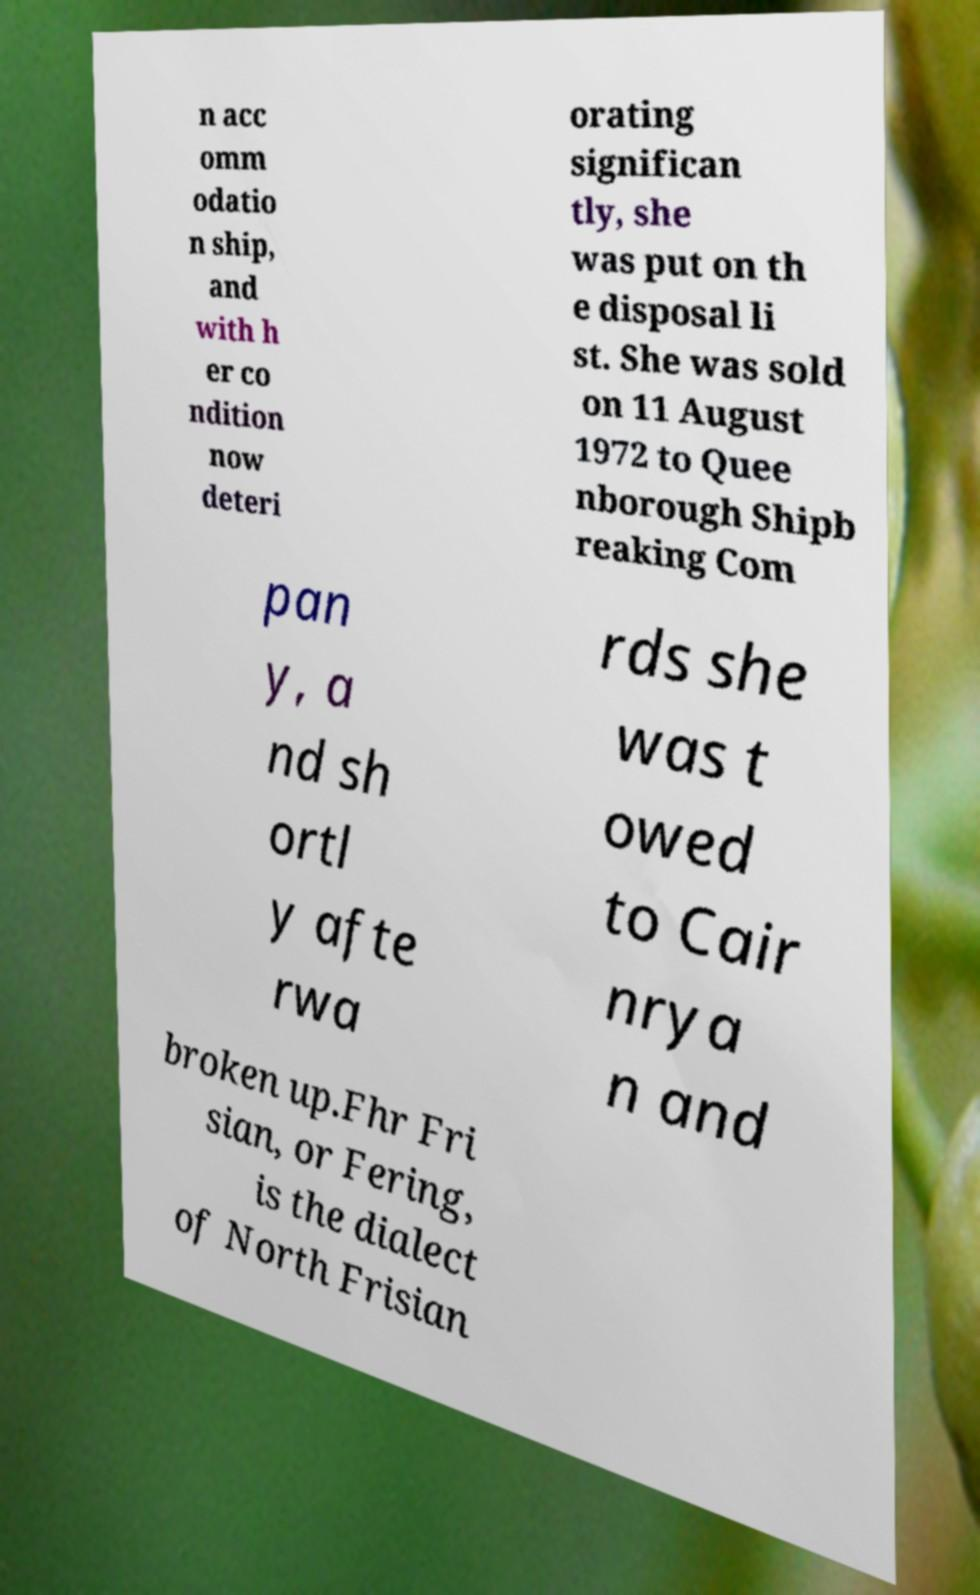I need the written content from this picture converted into text. Can you do that? n acc omm odatio n ship, and with h er co ndition now deteri orating significan tly, she was put on th e disposal li st. She was sold on 11 August 1972 to Quee nborough Shipb reaking Com pan y, a nd sh ortl y afte rwa rds she was t owed to Cair nrya n and broken up.Fhr Fri sian, or Fering, is the dialect of North Frisian 